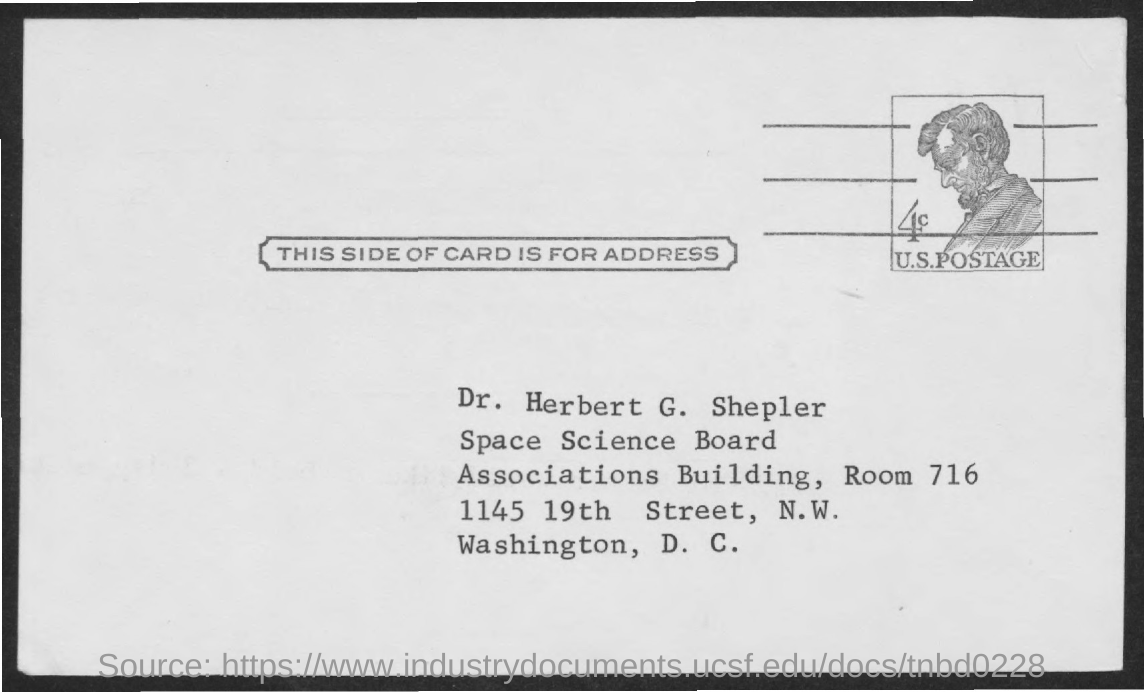What is the room number?
Offer a terse response. Room 716. What is the text written below the image?
Your response must be concise. U.s.postage. What is the title of the document?
Keep it short and to the point. This side of card is for address. 